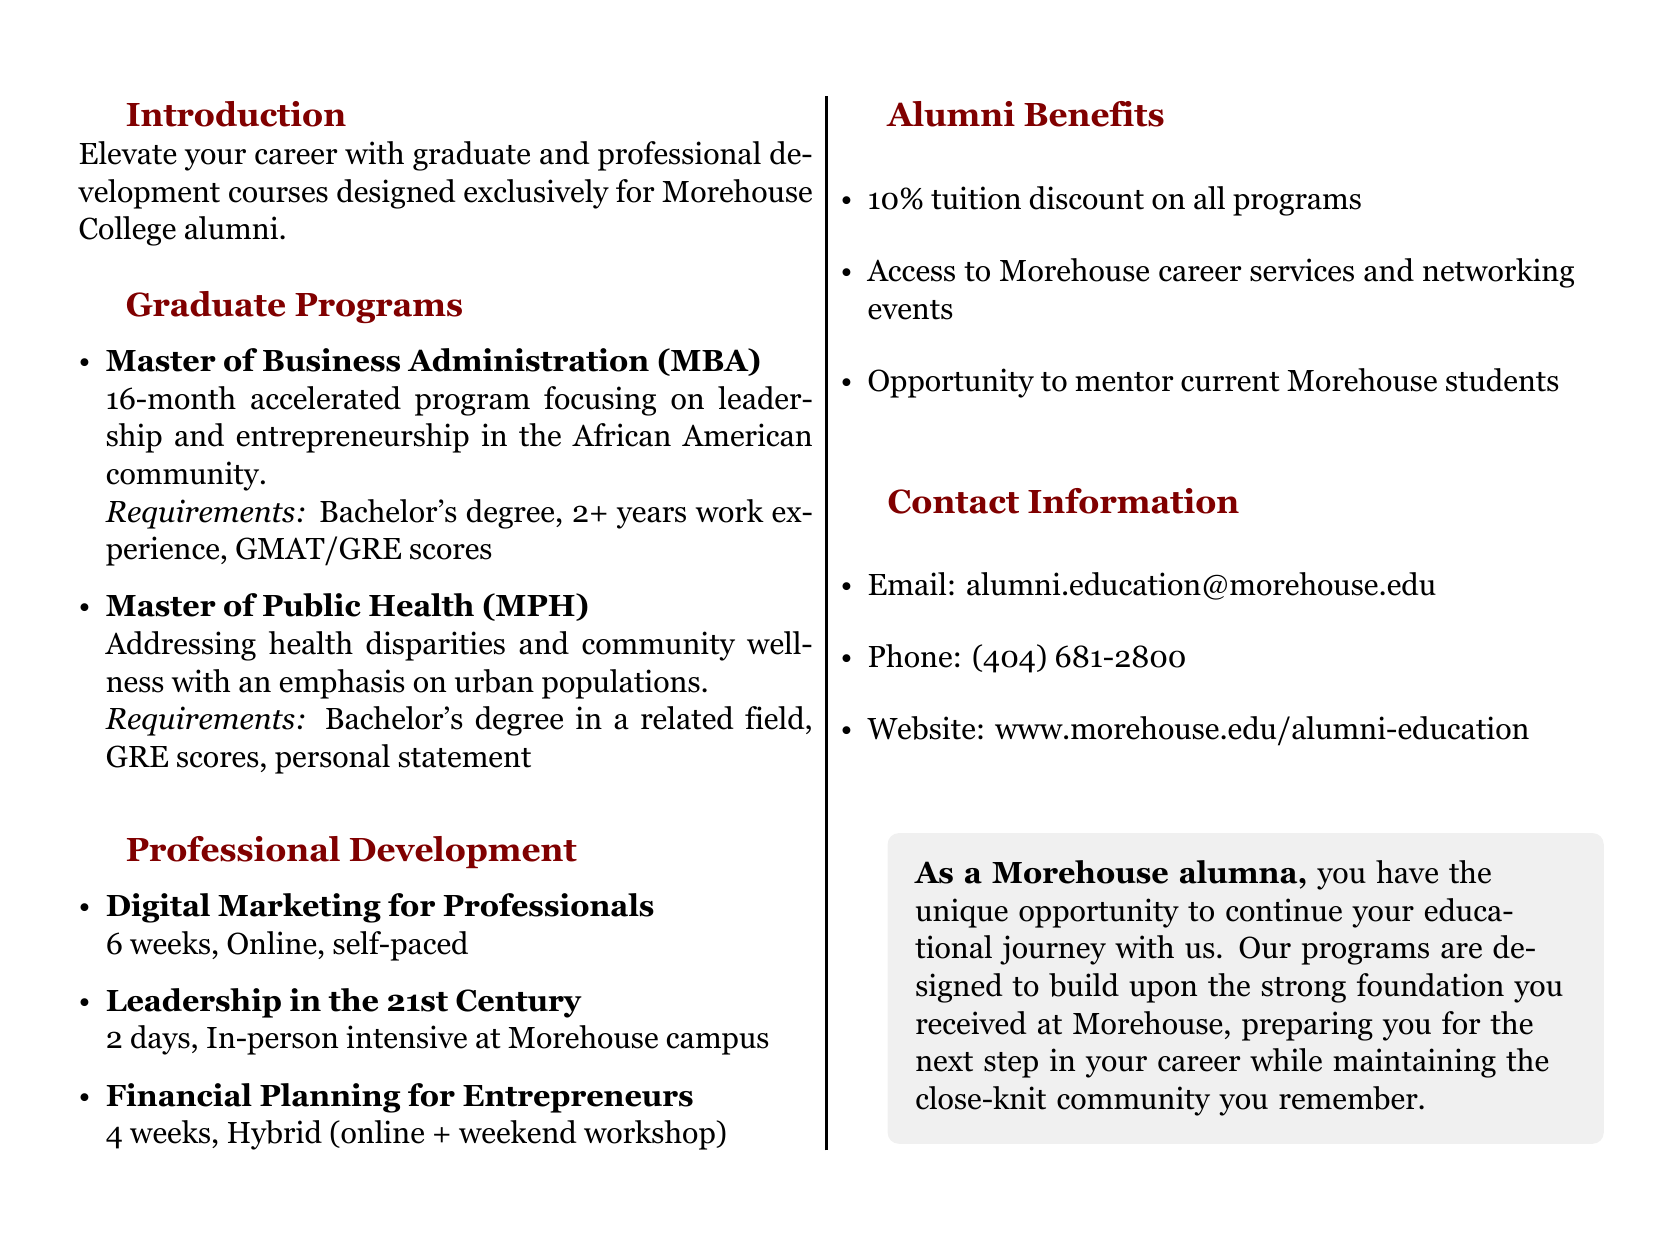What is the title of the program? The title of the program as mentioned in the document is "Morehouse Alumni Advanced Studies Program."
Answer: Morehouse Alumni Advanced Studies Program How long is the MBA program? The MBA program is described as a "16-month accelerated program" in the document.
Answer: 16-month What are the requirements for the Master of Public Health? The requirements list includes a bachelor's degree in a related field, GRE scores, and a personal statement.
Answer: Bachelor's degree in a related field, GRE scores, personal statement What is the duration of the Digital Marketing for Professionals course? The document states that the Digital Marketing for Professionals course lasts "6 weeks."
Answer: 6 weeks What type of courses are offered in the Professional Development section? The document lists specific types of courses, including digital marketing, leadership, and financial planning.
Answer: Digital Marketing for Professionals, Leadership in the 21st Century, Financial Planning for Entrepreneurs What is the alumni discount on tuition? The document indicates that alumni receive a "10% tuition discount on all programs."
Answer: 10% What kind of opportunities can alumni engage in according to the catalog? Alumni can engage in mentoring current Morehouse students as one of the benefits listed.
Answer: Mentor current Morehouse students Where can alumni find more information about the programs? The contact section provides an email and website for more inquiries, which includes the website URL.
Answer: www.morehouse.edu/alumni-education 